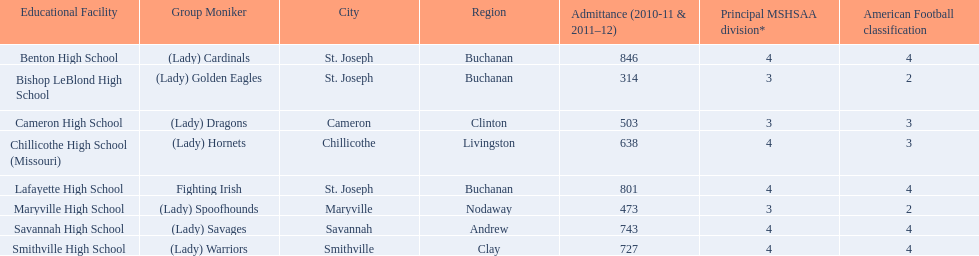Does lafayette high school or benton high school have green and grey as their colors? Lafayette High School. 